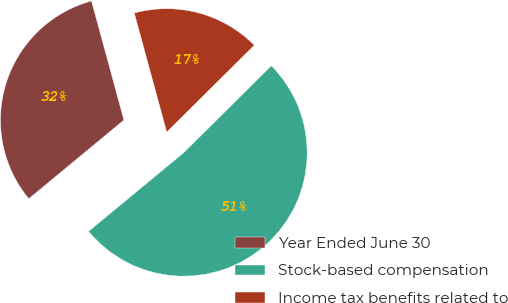Convert chart to OTSL. <chart><loc_0><loc_0><loc_500><loc_500><pie_chart><fcel>Year Ended June 30<fcel>Stock-based compensation<fcel>Income tax benefits related to<nl><fcel>31.77%<fcel>51.44%<fcel>16.79%<nl></chart> 